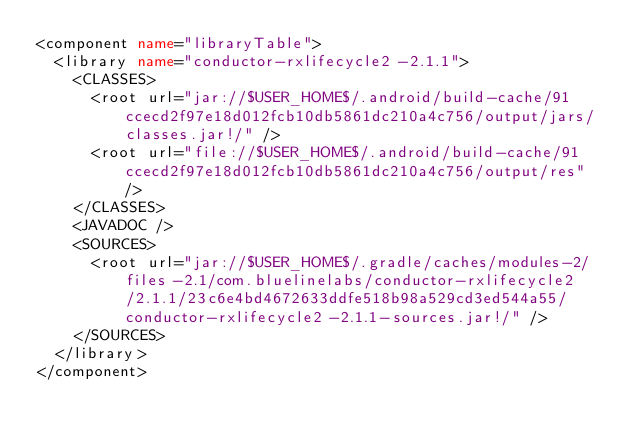Convert code to text. <code><loc_0><loc_0><loc_500><loc_500><_XML_><component name="libraryTable">
  <library name="conductor-rxlifecycle2-2.1.1">
    <CLASSES>
      <root url="jar://$USER_HOME$/.android/build-cache/91ccecd2f97e18d012fcb10db5861dc210a4c756/output/jars/classes.jar!/" />
      <root url="file://$USER_HOME$/.android/build-cache/91ccecd2f97e18d012fcb10db5861dc210a4c756/output/res" />
    </CLASSES>
    <JAVADOC />
    <SOURCES>
      <root url="jar://$USER_HOME$/.gradle/caches/modules-2/files-2.1/com.bluelinelabs/conductor-rxlifecycle2/2.1.1/23c6e4bd4672633ddfe518b98a529cd3ed544a55/conductor-rxlifecycle2-2.1.1-sources.jar!/" />
    </SOURCES>
  </library>
</component></code> 